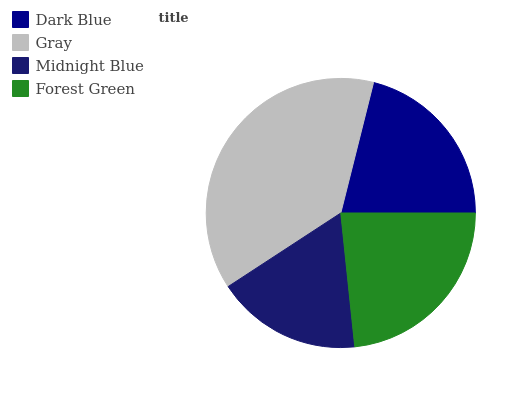Is Midnight Blue the minimum?
Answer yes or no. Yes. Is Gray the maximum?
Answer yes or no. Yes. Is Gray the minimum?
Answer yes or no. No. Is Midnight Blue the maximum?
Answer yes or no. No. Is Gray greater than Midnight Blue?
Answer yes or no. Yes. Is Midnight Blue less than Gray?
Answer yes or no. Yes. Is Midnight Blue greater than Gray?
Answer yes or no. No. Is Gray less than Midnight Blue?
Answer yes or no. No. Is Forest Green the high median?
Answer yes or no. Yes. Is Dark Blue the low median?
Answer yes or no. Yes. Is Midnight Blue the high median?
Answer yes or no. No. Is Gray the low median?
Answer yes or no. No. 